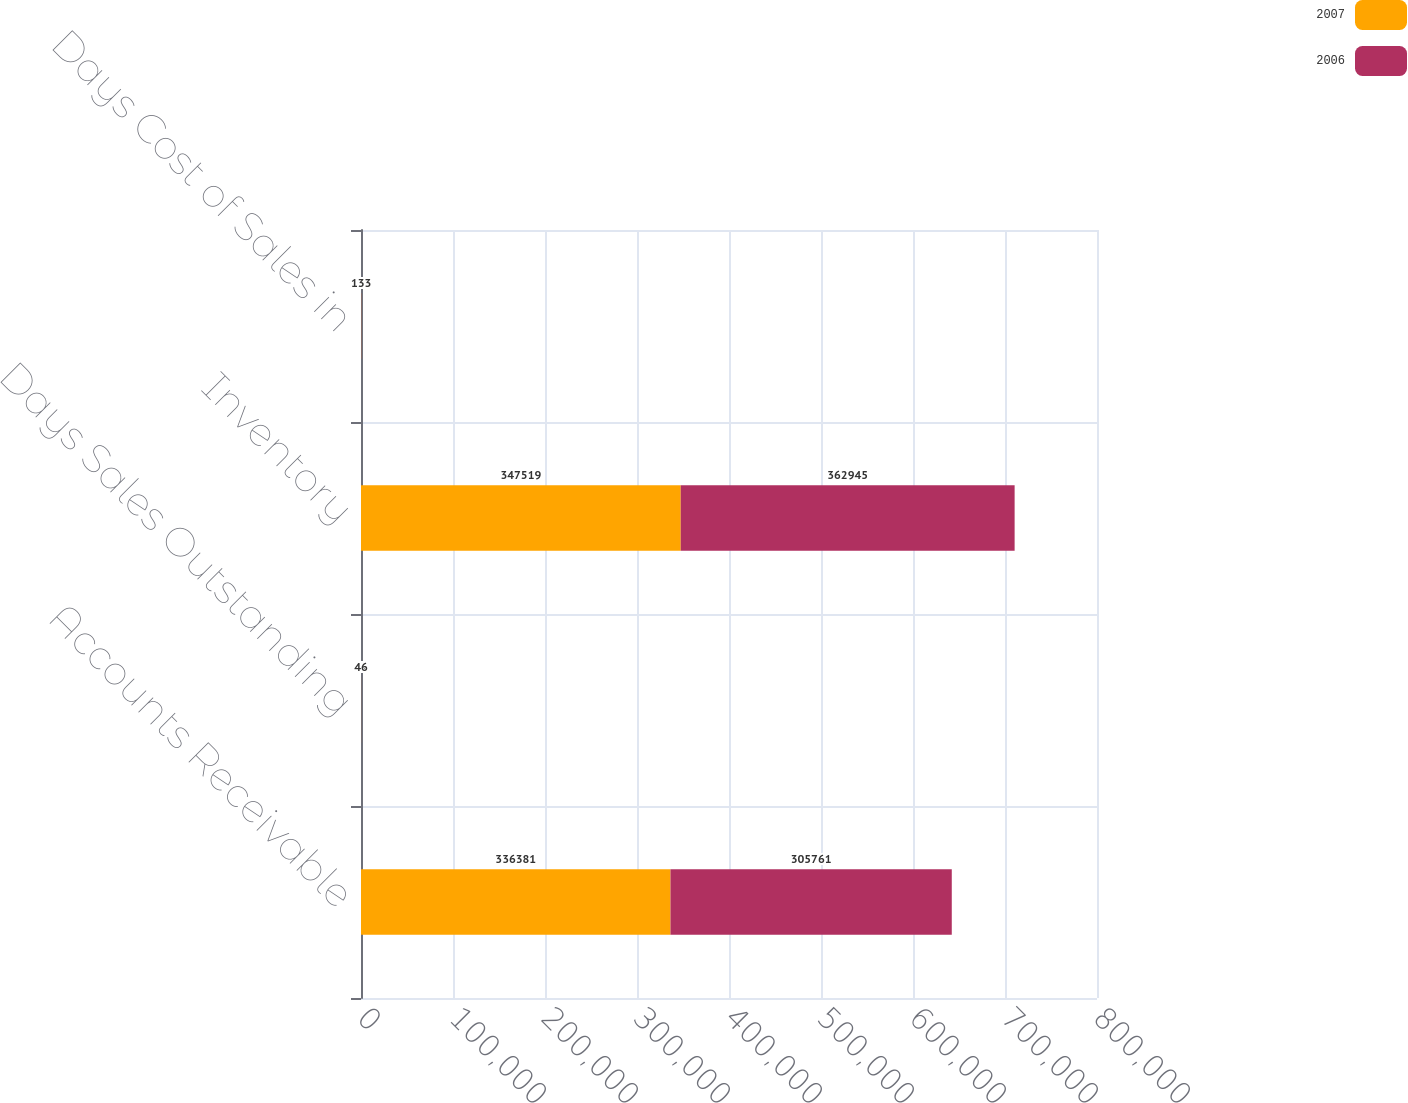<chart> <loc_0><loc_0><loc_500><loc_500><stacked_bar_chart><ecel><fcel>Accounts Receivable<fcel>Days Sales Outstanding<fcel>Inventory<fcel>Days Cost of Sales in<nl><fcel>2007<fcel>336381<fcel>47<fcel>347519<fcel>118<nl><fcel>2006<fcel>305761<fcel>46<fcel>362945<fcel>133<nl></chart> 